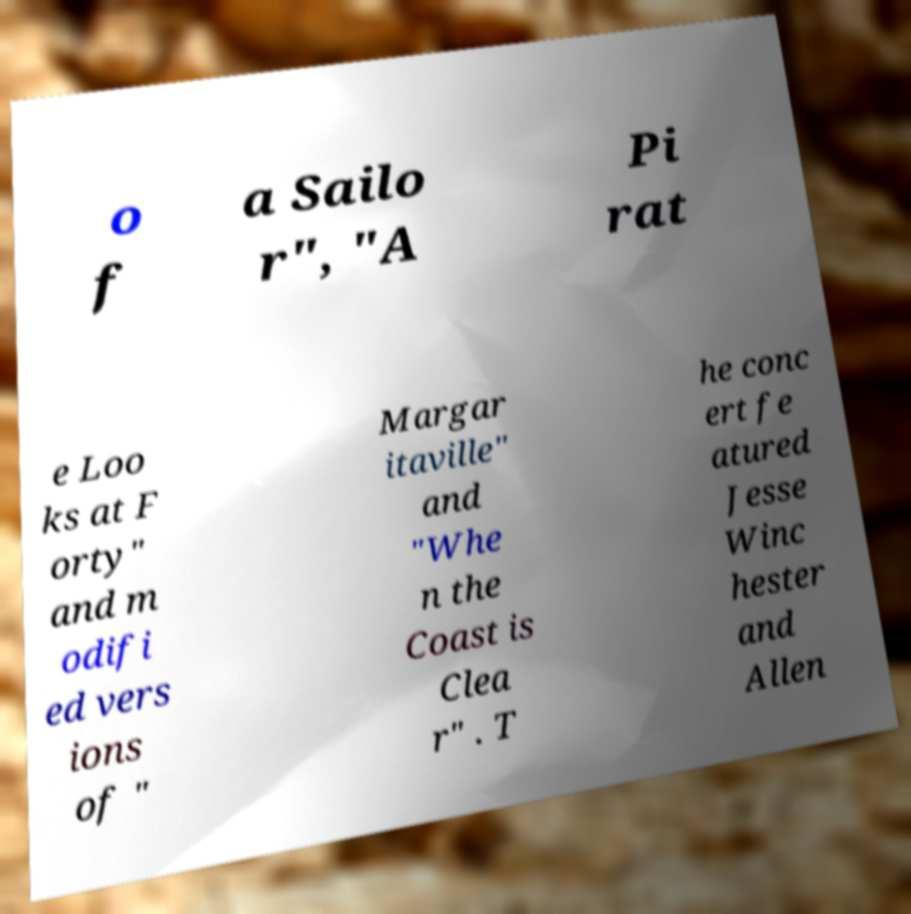Can you read and provide the text displayed in the image?This photo seems to have some interesting text. Can you extract and type it out for me? o f a Sailo r", "A Pi rat e Loo ks at F orty" and m odifi ed vers ions of " Margar itaville" and "Whe n the Coast is Clea r" . T he conc ert fe atured Jesse Winc hester and Allen 